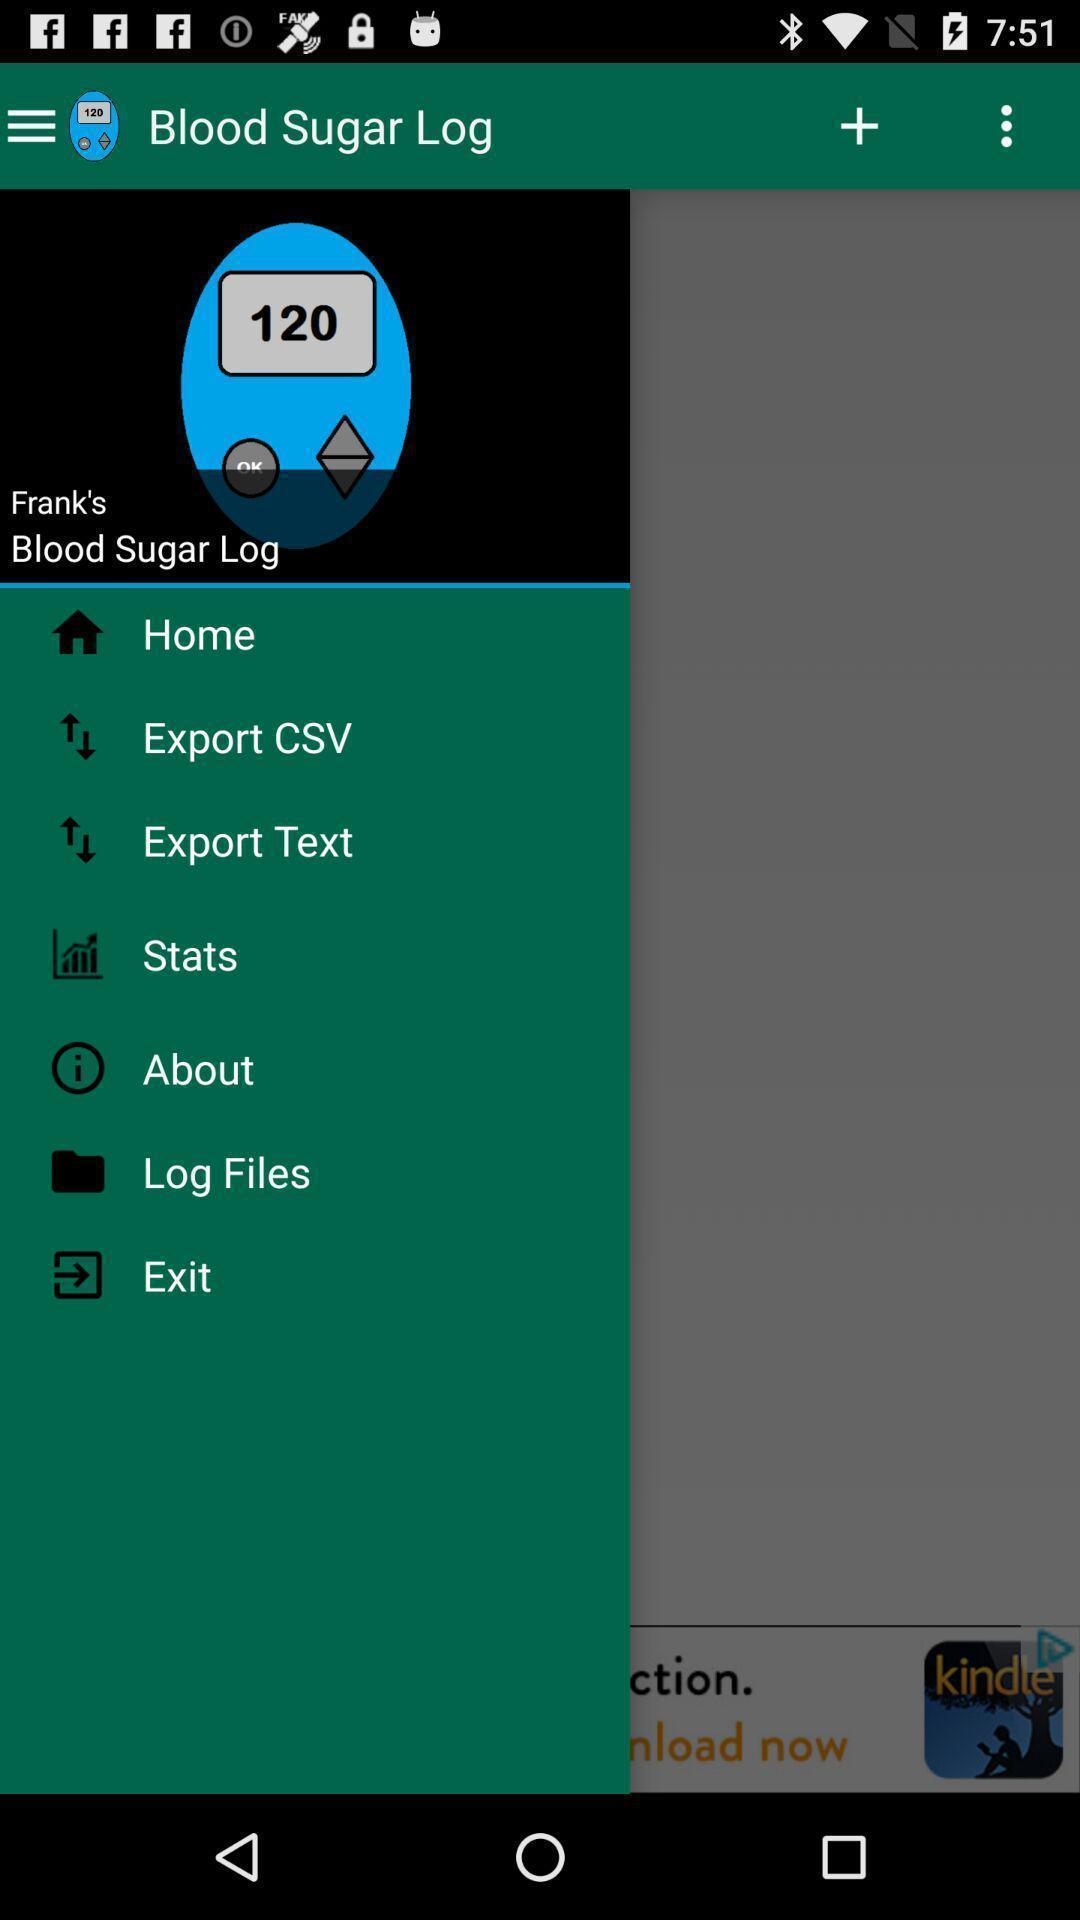Tell me about the visual elements in this screen capture. Window displaying a medical app. 